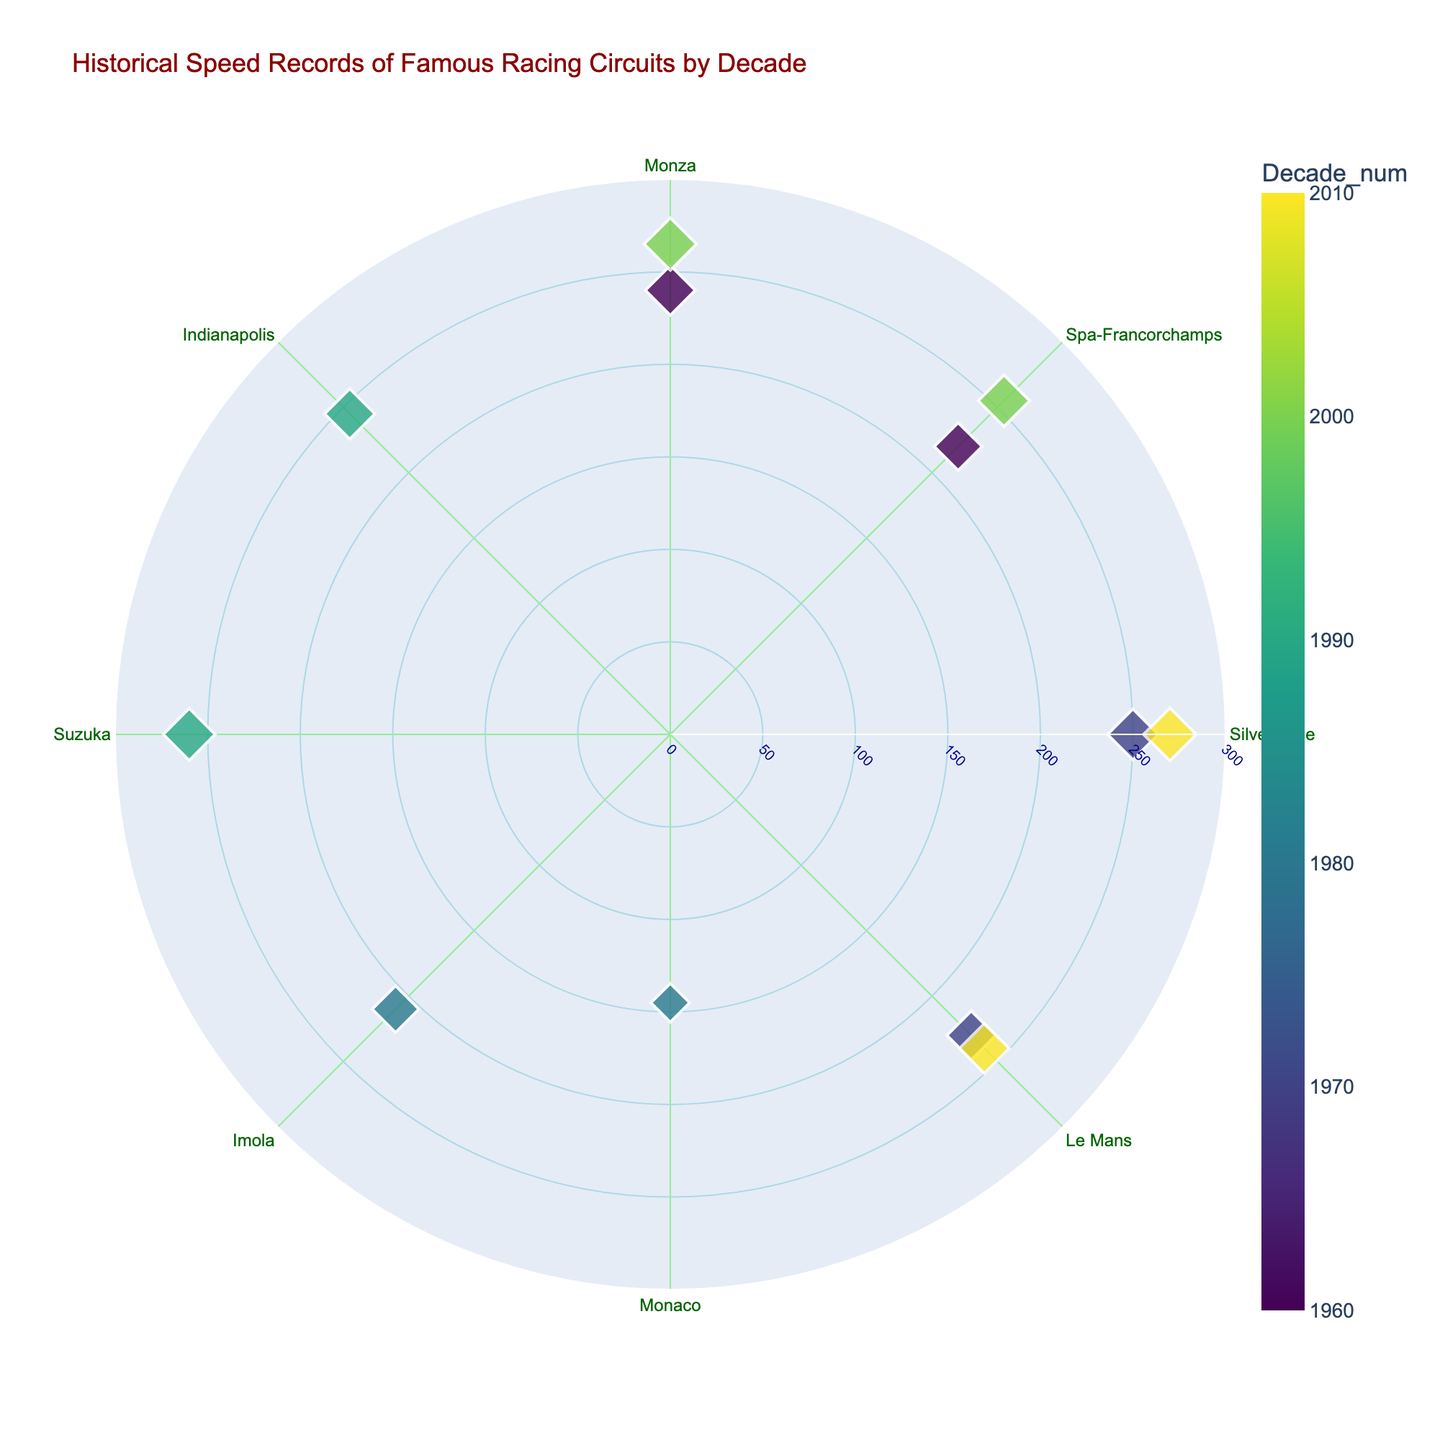1. What is the record speed for Monza in the 2000s? Identify the Monza circuit labeled in the 2000s and check the corresponding speed value, which is 265 km/h.
Answer: 265 km/h 2. Which decade's data points are represented with the darkest color? The color scale ranges from light to dark, with the darkest color representing the oldest decade. The 1960s have the darkest color.
Answer: 1960s 3. How many circuits have a speed record above 250 km/h? Count all the data points with speeds greater than 250 km/h: Silverstone (270), Suzuka (260), Monza (265), and Spa-Francorchamps (255).
Answer: 4 4. What is the difference in speed between the fastest and slowest records in the 2010s? The fastest record in the 2010s is Silverstone with 270 km/h, and the slowest is Le Mans with 240 km/h. The difference is 270 - 240 = 30 km/h.
Answer: 30 km/h 5. Who holds the speed record for Monaco, and what is the value? Identify the data point for Monaco and read the driver and speed: Ayrton Senna at 145 km/h.
Answer: Ayrton Senna, 145 km/h 6. Among Monza and Imola, which circuit has a higher speed record in its respective decade? Compare the speeds for Monza (240 km/h in the 1960s) and Imola (210 km/h in the 1980s). Monza has a higher speed record.
Answer: Monza 7. Is there any circuit that appears in both the 1960s and 2000s? Check if there is any circuit listed under both the 1960s and 2000s: Monza appears in both decades.
Answer: Yes, Monza 8. What is the average speed record for circuits in the 1990s? Calculate the average of speeds from Suzuka (260 km/h) and Indianapolis (245 km/h): (260 + 245) / 2 = 252.5 km/h.
Answer: 252.5 km/h 9. Which decade has the highest recorded speed value, and which circuit does it belong to? Identify the decade with the highest speed: 2010s (270 km/h by Lewis Hamilton at Silverstone).
Answer: 2010s, Silverstone 10. What is the median speed value of the given data? List all speeds and find the median: 145, 210, 220, 230, 240, 240, 245, 250, 255, 260, 265, 270. The median is the average of the two middle values (240 + 245) / 2 = 242.5 km/h.
Answer: 242.5 km/h 